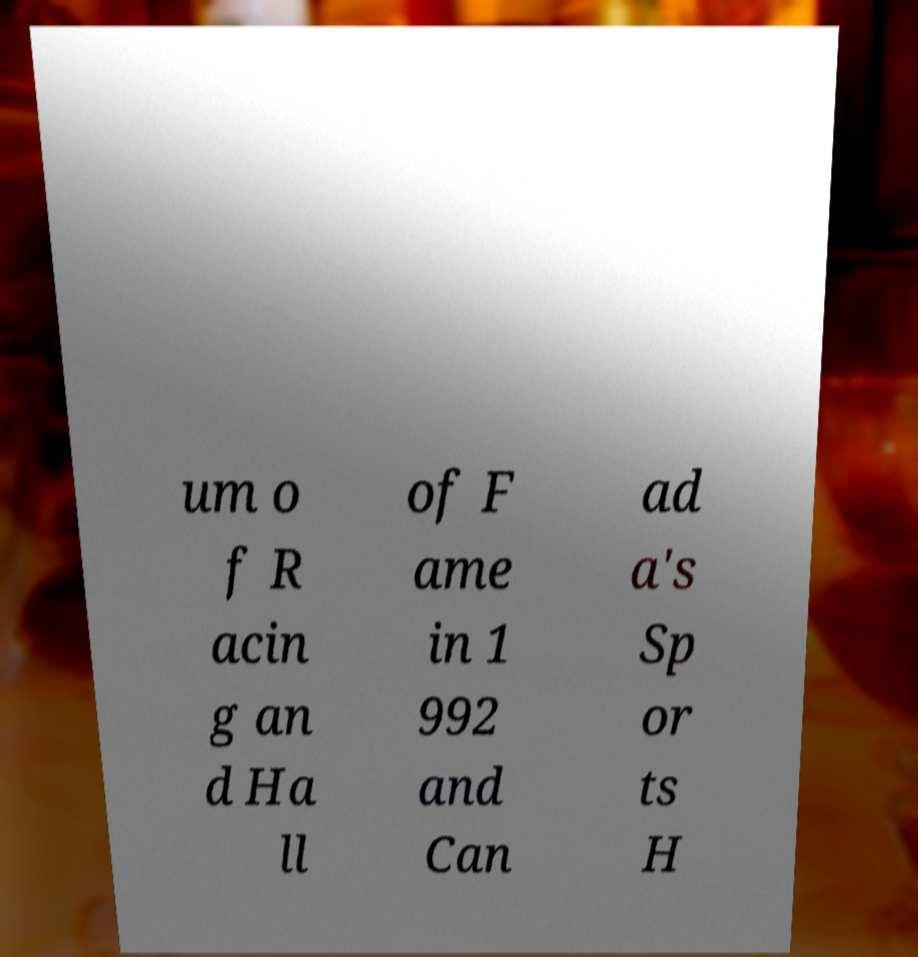Can you read and provide the text displayed in the image?This photo seems to have some interesting text. Can you extract and type it out for me? um o f R acin g an d Ha ll of F ame in 1 992 and Can ad a's Sp or ts H 